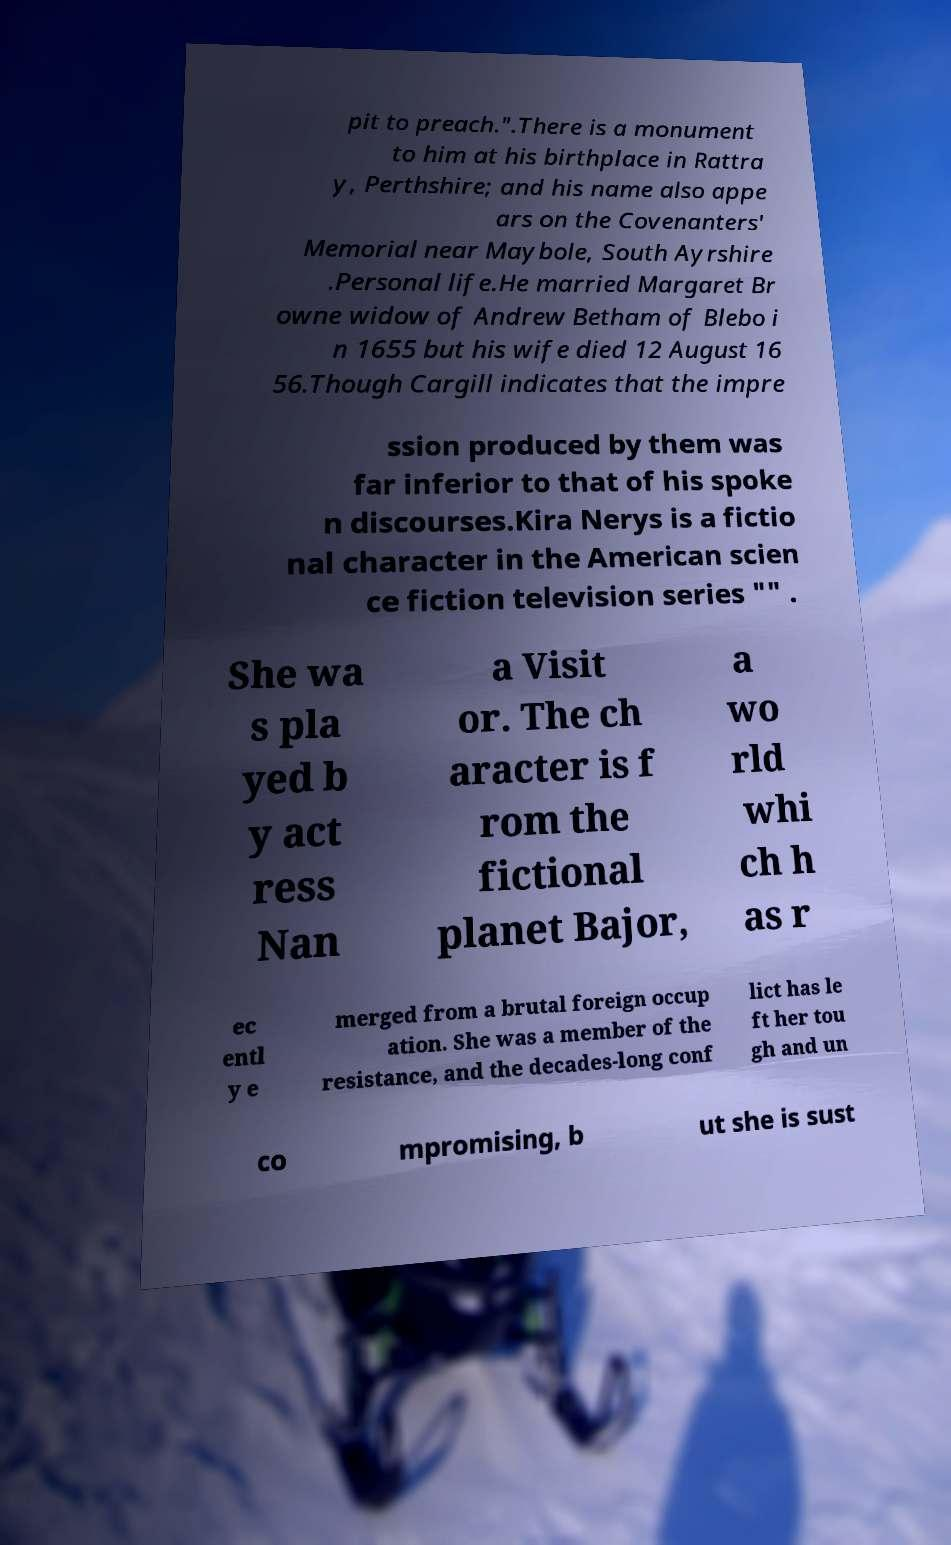Can you read and provide the text displayed in the image?This photo seems to have some interesting text. Can you extract and type it out for me? pit to preach.".There is a monument to him at his birthplace in Rattra y, Perthshire; and his name also appe ars on the Covenanters' Memorial near Maybole, South Ayrshire .Personal life.He married Margaret Br owne widow of Andrew Betham of Blebo i n 1655 but his wife died 12 August 16 56.Though Cargill indicates that the impre ssion produced by them was far inferior to that of his spoke n discourses.Kira Nerys is a fictio nal character in the American scien ce fiction television series "" . She wa s pla yed b y act ress Nan a Visit or. The ch aracter is f rom the fictional planet Bajor, a wo rld whi ch h as r ec entl y e merged from a brutal foreign occup ation. She was a member of the resistance, and the decades-long conf lict has le ft her tou gh and un co mpromising, b ut she is sust 